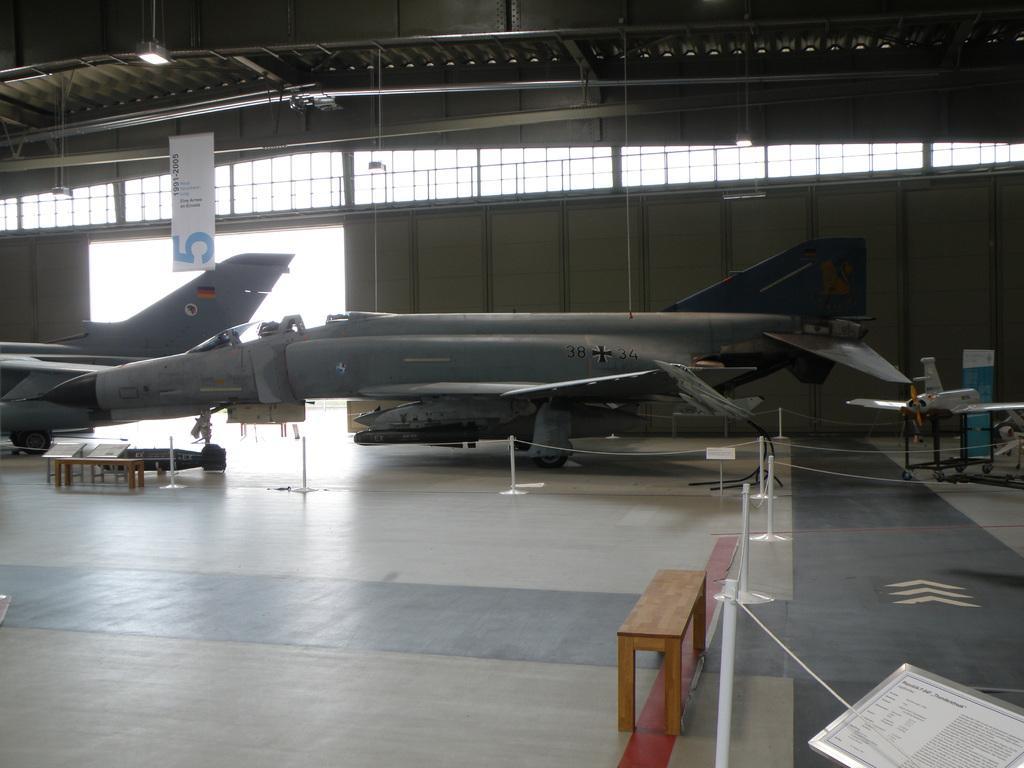How would you summarize this image in a sentence or two? In this image we can see aircraft's on the surface. There are safety poles. There is a table. At the top of the image there is ceiling. In the background of the image there is wall. There is a white color banner with some text. 